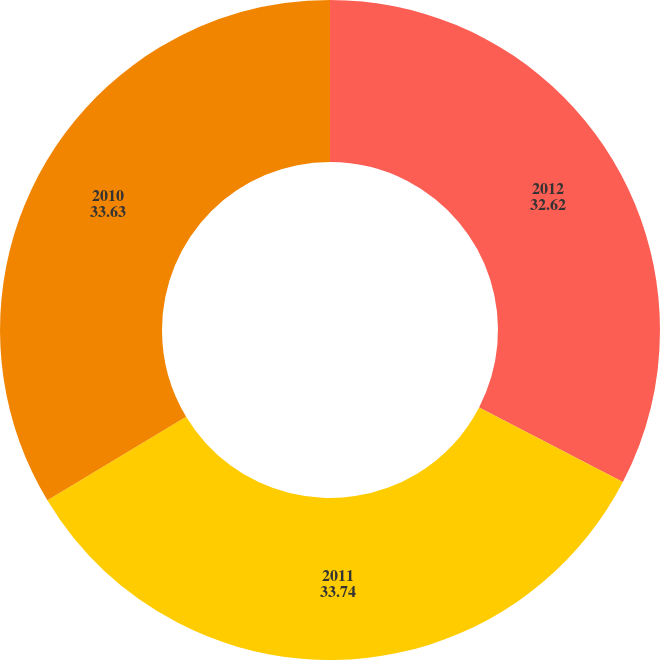<chart> <loc_0><loc_0><loc_500><loc_500><pie_chart><fcel>2012<fcel>2011<fcel>2010<nl><fcel>32.62%<fcel>33.74%<fcel>33.63%<nl></chart> 